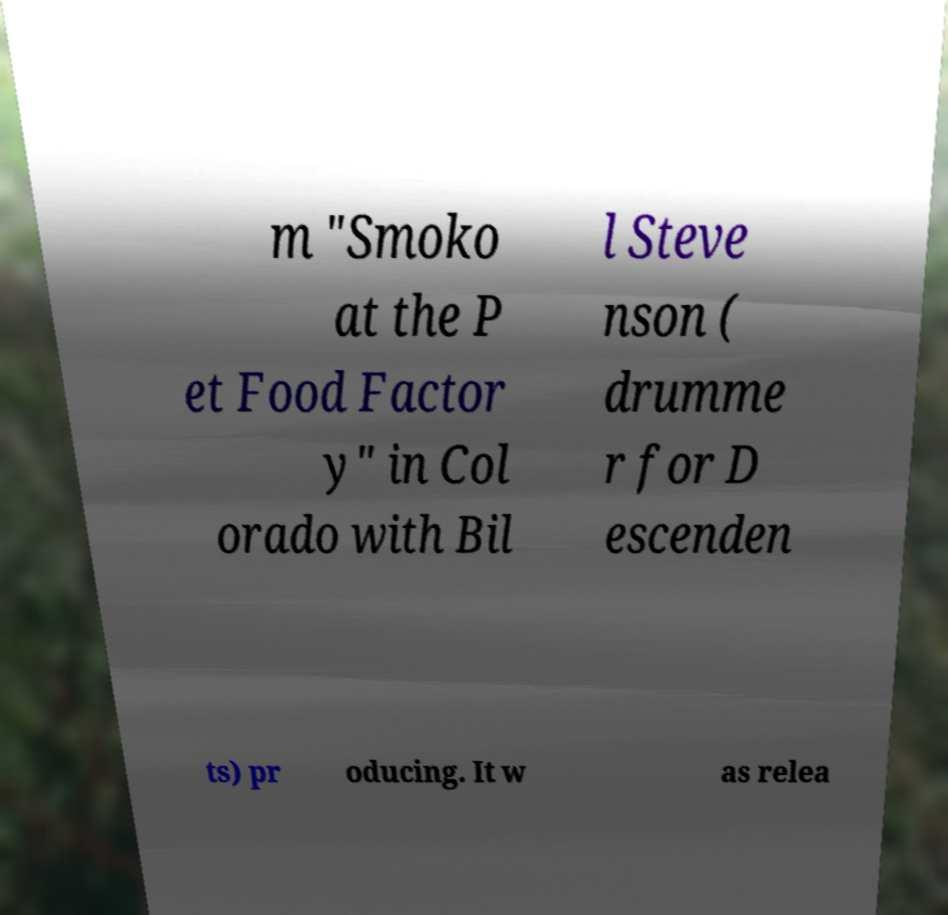Please identify and transcribe the text found in this image. m "Smoko at the P et Food Factor y" in Col orado with Bil l Steve nson ( drumme r for D escenden ts) pr oducing. It w as relea 